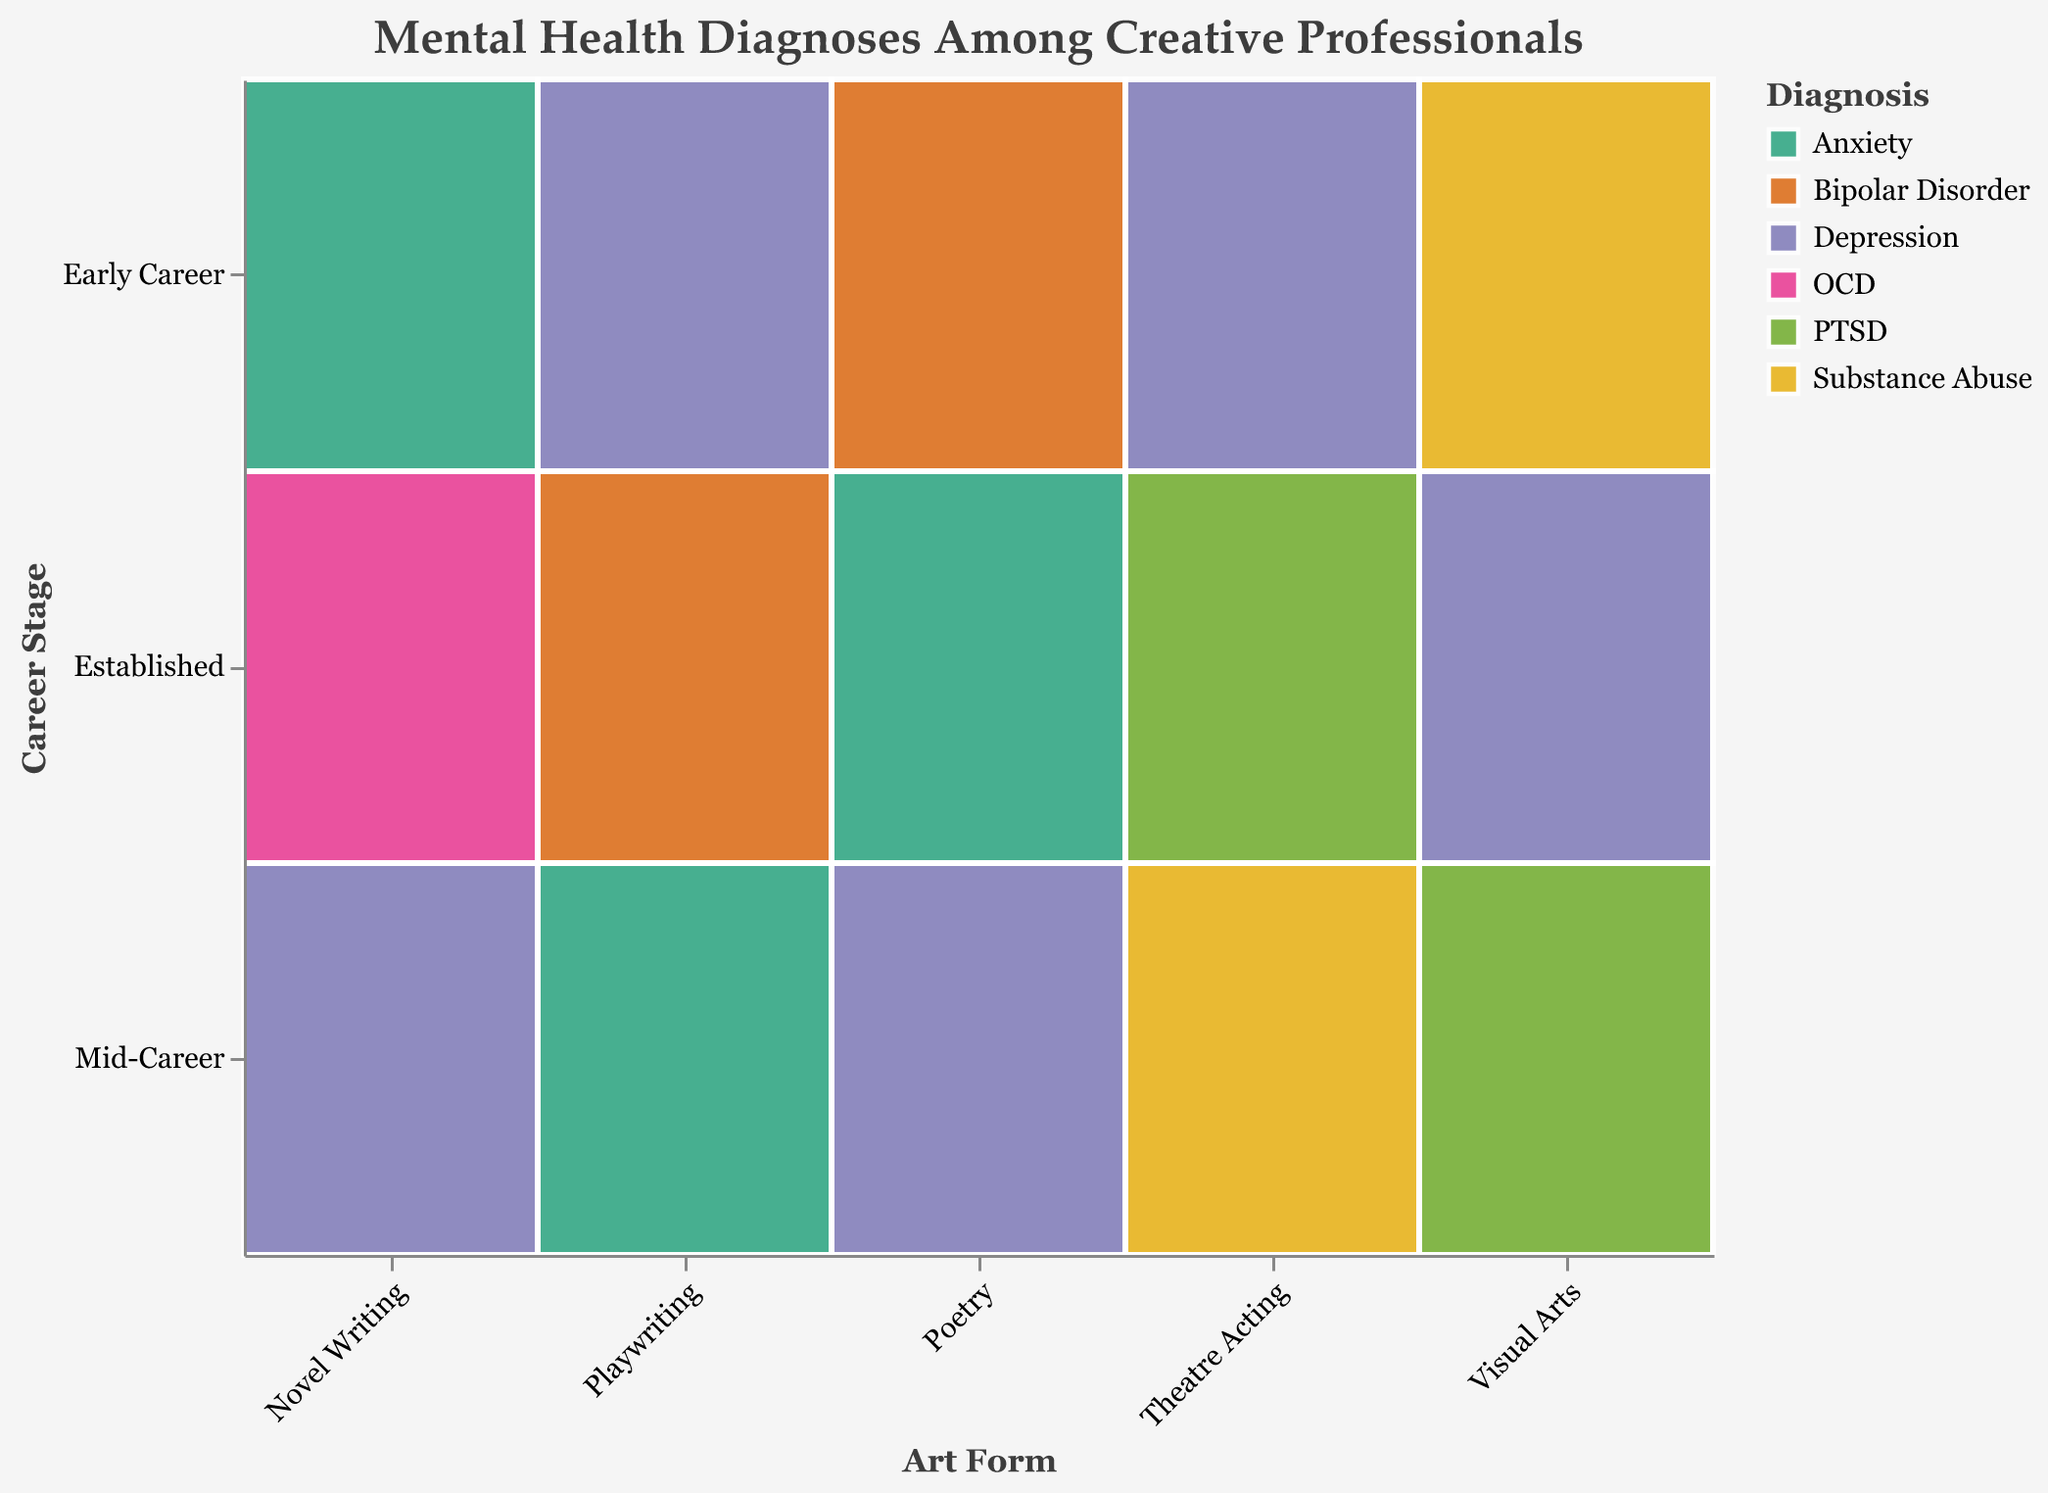What is the title of the figure? The title is displayed at the top of the figure.
Answer: Mental Health Diagnoses Among Creative Professionals Which career stage in playwriting has the highest count? By looking at the size representation in playwriting's career stages, 'Mid-Career' has the largest size.
Answer: Mid-Career What diagnosis is most prevalent among early career professionals in theatre acting? Check the 'Early Career' stages for Theatre Acting; find color and size to determine the most prevalent diagnosis.
Answer: Depression Between novel writing and poetry in mid-career, which has a higher count of diagnoses? Compare the sizes of mid-career segments for Novel Writing and Poetry. Novel Writing has a larger size.
Answer: Novel Writing What's the total count of depression diagnosis cases across all art forms? Sum the counts of depression in different art forms (28 + 42 + 45 + 33 + 38).
Answer: 186 Which career stage in visual arts has the minimum count? Compare the sizes of all career stages in Visual Arts. 'Mid-Career' has the smallest size.
Answer: Mid-Career Is anxiety more common in early career or established career stages in any art form? Check the sizes of 'Anxiety' diagnosis color in early career and established career stages across all art forms.
Answer: Established Career What mental health issue is prevalent among established playwrights? Look at the diagnosis in the 'Established' career stage for playwriting.
Answer: Bipolar Disorder How does the count of substance abuse in theatre acting mid-career compare with visual arts early career? Compare the sizes of 'Substance Abuse' in both Theatre Acting Mid-Career and Visual Arts Early Career. Theatre Acting Mid-Career has a larger size.
Answer: Theatre Acting Mid-Career Across all art forms, which career stage shows the highest count of PTSD diagnoses? Check the sizes representing PTSD diagnosis across all career stages. Theatre Acting Established and Visual Arts Mid-Career both have PTSD, but Theatre Acting Established has a larger size.
Answer: Theatre Acting Established 